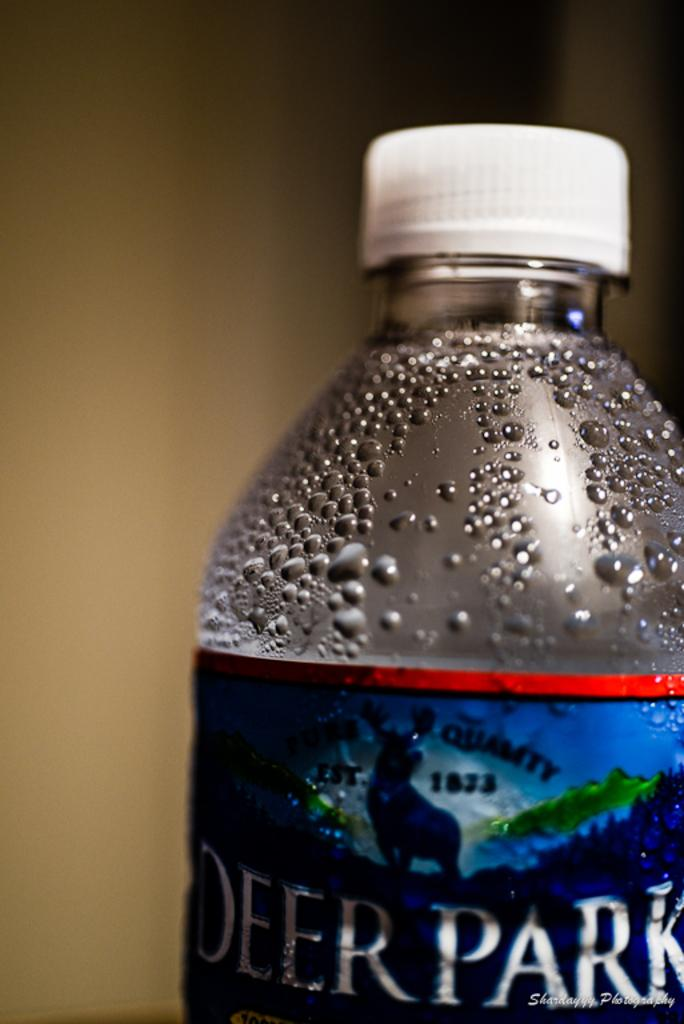<image>
Create a compact narrative representing the image presented. Water bottle with white cap and has on blue label the words Deer Park. 